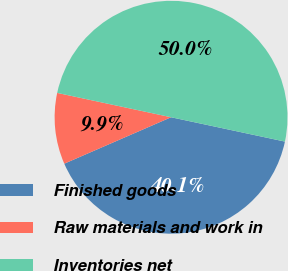Convert chart to OTSL. <chart><loc_0><loc_0><loc_500><loc_500><pie_chart><fcel>Finished goods<fcel>Raw materials and work in<fcel>Inventories net<nl><fcel>40.12%<fcel>9.88%<fcel>50.0%<nl></chart> 